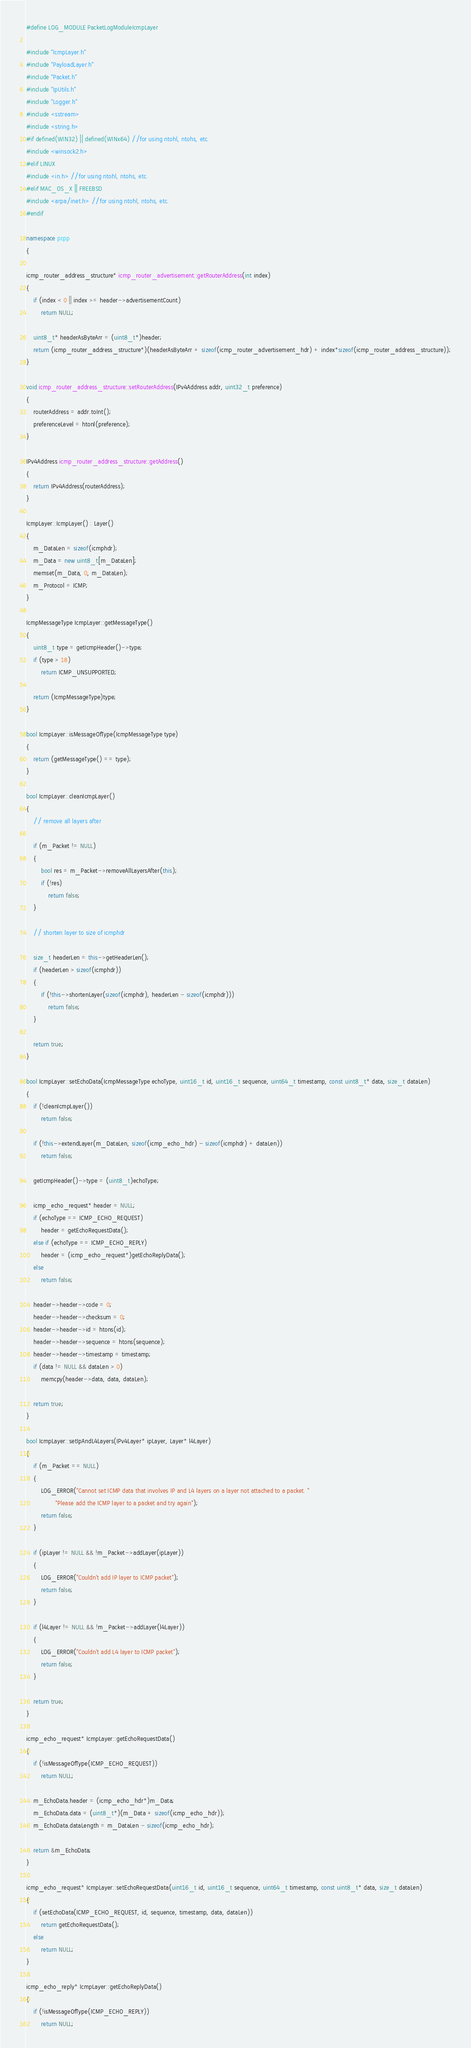Convert code to text. <code><loc_0><loc_0><loc_500><loc_500><_C++_>#define LOG_MODULE PacketLogModuleIcmpLayer

#include "IcmpLayer.h"
#include "PayloadLayer.h"
#include "Packet.h"
#include "IpUtils.h"
#include "Logger.h"
#include <sstream>
#include <string.h>
#if defined(WIN32) || defined(WINx64) //for using ntohl, ntohs, etc.
#include <winsock2.h>
#elif LINUX
#include <in.h> //for using ntohl, ntohs, etc.
#elif MAC_OS_X || FREEBSD
#include <arpa/inet.h> //for using ntohl, ntohs, etc.
#endif

namespace pcpp
{

icmp_router_address_structure* icmp_router_advertisement::getRouterAddress(int index)
{
	if (index < 0 || index >= header->advertisementCount)
		return NULL;

	uint8_t* headerAsByteArr = (uint8_t*)header;
	return (icmp_router_address_structure*)(headerAsByteArr + sizeof(icmp_router_advertisement_hdr) + index*sizeof(icmp_router_address_structure));
}

void icmp_router_address_structure::setRouterAddress(IPv4Address addr, uint32_t preference)
{
	routerAddress = addr.toInt();
	preferenceLevel = htonl(preference);
}

IPv4Address icmp_router_address_structure::getAddress()
{
	return IPv4Address(routerAddress);
}

IcmpLayer::IcmpLayer() : Layer()
{
	m_DataLen = sizeof(icmphdr);
	m_Data = new uint8_t[m_DataLen];
	memset(m_Data, 0, m_DataLen);
	m_Protocol = ICMP;
}

IcmpMessageType IcmpLayer::getMessageType()
{
	uint8_t type = getIcmpHeader()->type;
	if (type > 18)
		return ICMP_UNSUPPORTED;

	return (IcmpMessageType)type;
}

bool IcmpLayer::isMessageOfType(IcmpMessageType type)
{
	return (getMessageType() == type);
}

bool IcmpLayer::cleanIcmpLayer()
{
	// remove all layers after

	if (m_Packet != NULL)
	{
		bool res = m_Packet->removeAllLayersAfter(this);
		if (!res)
			return false;
	}

	// shorten layer to size of icmphdr

	size_t headerLen = this->getHeaderLen();
	if (headerLen > sizeof(icmphdr))
	{
		if (!this->shortenLayer(sizeof(icmphdr), headerLen - sizeof(icmphdr)))
			return false;
	}

	return true;
}

bool IcmpLayer::setEchoData(IcmpMessageType echoType, uint16_t id, uint16_t sequence, uint64_t timestamp, const uint8_t* data, size_t dataLen)
{
	if (!cleanIcmpLayer())
		return false;

	if (!this->extendLayer(m_DataLen, sizeof(icmp_echo_hdr) - sizeof(icmphdr) + dataLen))
		return false;

	getIcmpHeader()->type = (uint8_t)echoType;

	icmp_echo_request* header = NULL;
	if (echoType == ICMP_ECHO_REQUEST)
		header = getEchoRequestData();
	else if (echoType == ICMP_ECHO_REPLY)
		header = (icmp_echo_request*)getEchoReplyData();
	else
		return false;

	header->header->code = 0;
	header->header->checksum = 0;
	header->header->id = htons(id);
	header->header->sequence = htons(sequence);
	header->header->timestamp = timestamp;
	if (data != NULL && dataLen > 0)
		memcpy(header->data, data, dataLen);

	return true;
}

bool IcmpLayer::setIpAndL4Layers(IPv4Layer* ipLayer, Layer* l4Layer)
{
	if (m_Packet == NULL)
	{
		LOG_ERROR("Cannot set ICMP data that involves IP and L4 layers on a layer not attached to a packet. "
				"Please add the ICMP layer to a packet and try again");
		return false;
	}

	if (ipLayer != NULL && !m_Packet->addLayer(ipLayer))
	{
		LOG_ERROR("Couldn't add IP layer to ICMP packet");
		return false;
	}

	if (l4Layer != NULL && !m_Packet->addLayer(l4Layer))
	{
		LOG_ERROR("Couldn't add L4 layer to ICMP packet");
		return false;
	}

	return true;
}

icmp_echo_request* IcmpLayer::getEchoRequestData()
{
	if (!isMessageOfType(ICMP_ECHO_REQUEST))
		return NULL;

	m_EchoData.header = (icmp_echo_hdr*)m_Data;
	m_EchoData.data = (uint8_t*)(m_Data + sizeof(icmp_echo_hdr));
	m_EchoData.dataLength = m_DataLen - sizeof(icmp_echo_hdr);

	return &m_EchoData;
}

icmp_echo_request* IcmpLayer::setEchoRequestData(uint16_t id, uint16_t sequence, uint64_t timestamp, const uint8_t* data, size_t dataLen)
{
	if (setEchoData(ICMP_ECHO_REQUEST, id, sequence, timestamp, data, dataLen))
		return getEchoRequestData();
	else
		return NULL;
}

icmp_echo_reply* IcmpLayer::getEchoReplyData()
{
	if (!isMessageOfType(ICMP_ECHO_REPLY))
		return NULL;
</code> 